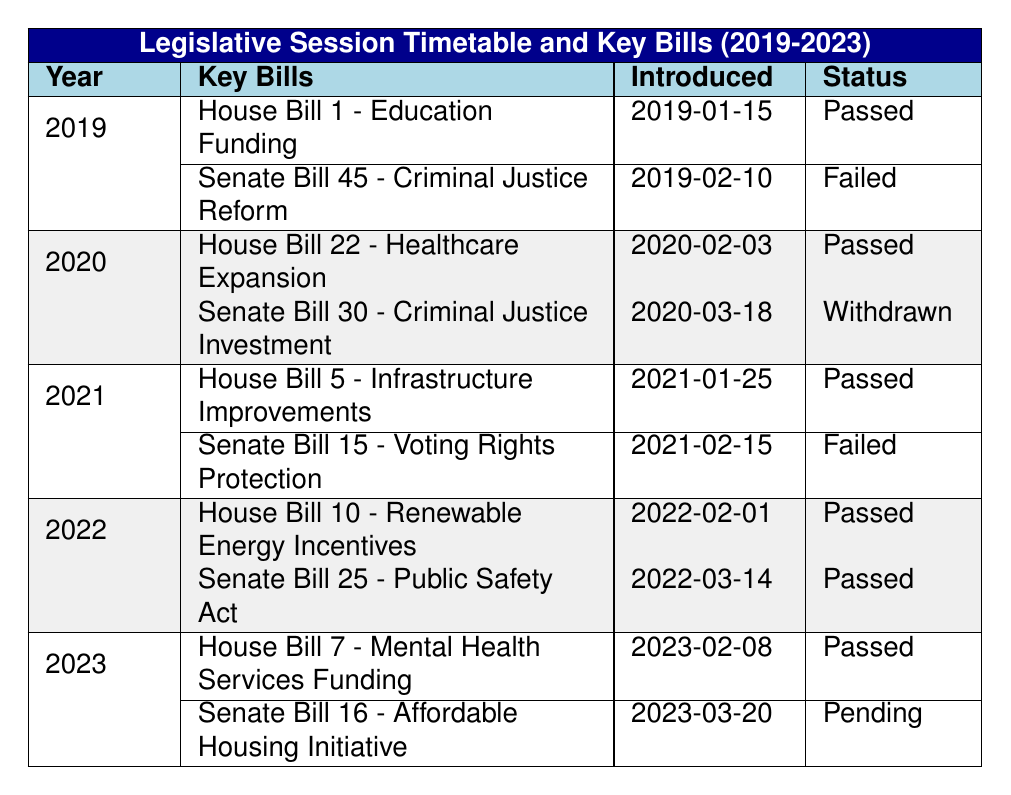What was the status of House Bill 22 in 2020? House Bill 22 was introduced on February 3, 2020, and its status is listed as "Passed."
Answer: Passed How many key bills were introduced in 2021? In 2021, there were two key bills introduced, House Bill 5 and Senate Bill 15.
Answer: 2 Was Senate Bill 30 passed in 2020? Senate Bill 30 was introduced on March 18, 2020, and was labeled as "Withdrawn," meaning it did not pass.
Answer: No Which year had the most key bills labeled as "Passed"? Reviewing the years, both 2022 and 2023 had two key bills that were passed, which is the highest count observed in these sessions.
Answer: 2022 and 2023 What is the difference in the number of bills passed between the years 2019 and 2022? In 2019, one bill was passed (House Bill 1), and in 2022, two bills were passed (House Bill 10 and Senate Bill 25). The difference is 2 - 1 = 1.
Answer: 1 In which year was the "Affordable Housing Initiative" introduced, and what is its current status? The "Affordable Housing Initiative" was introduced in 2023 on March 20, and as of the last update, its status is "Pending."
Answer: 2023, Pending Was there a pattern in the status of criminal justice-related bills introduced from 2019 to 2023? In 2019 and 2021, the bills related to criminal justice reform failed, while in 2020, it was withdrawn, and 2022 had none, indicating a trend of difficulty in passing criminal justice-related legislation in this timeframe.
Answer: Yes What percentage of key bills passed in 2023? In 2023, one out of the two bills introduced was passed, so the percentage is (1/2) * 100 = 50%.
Answer: 50% 